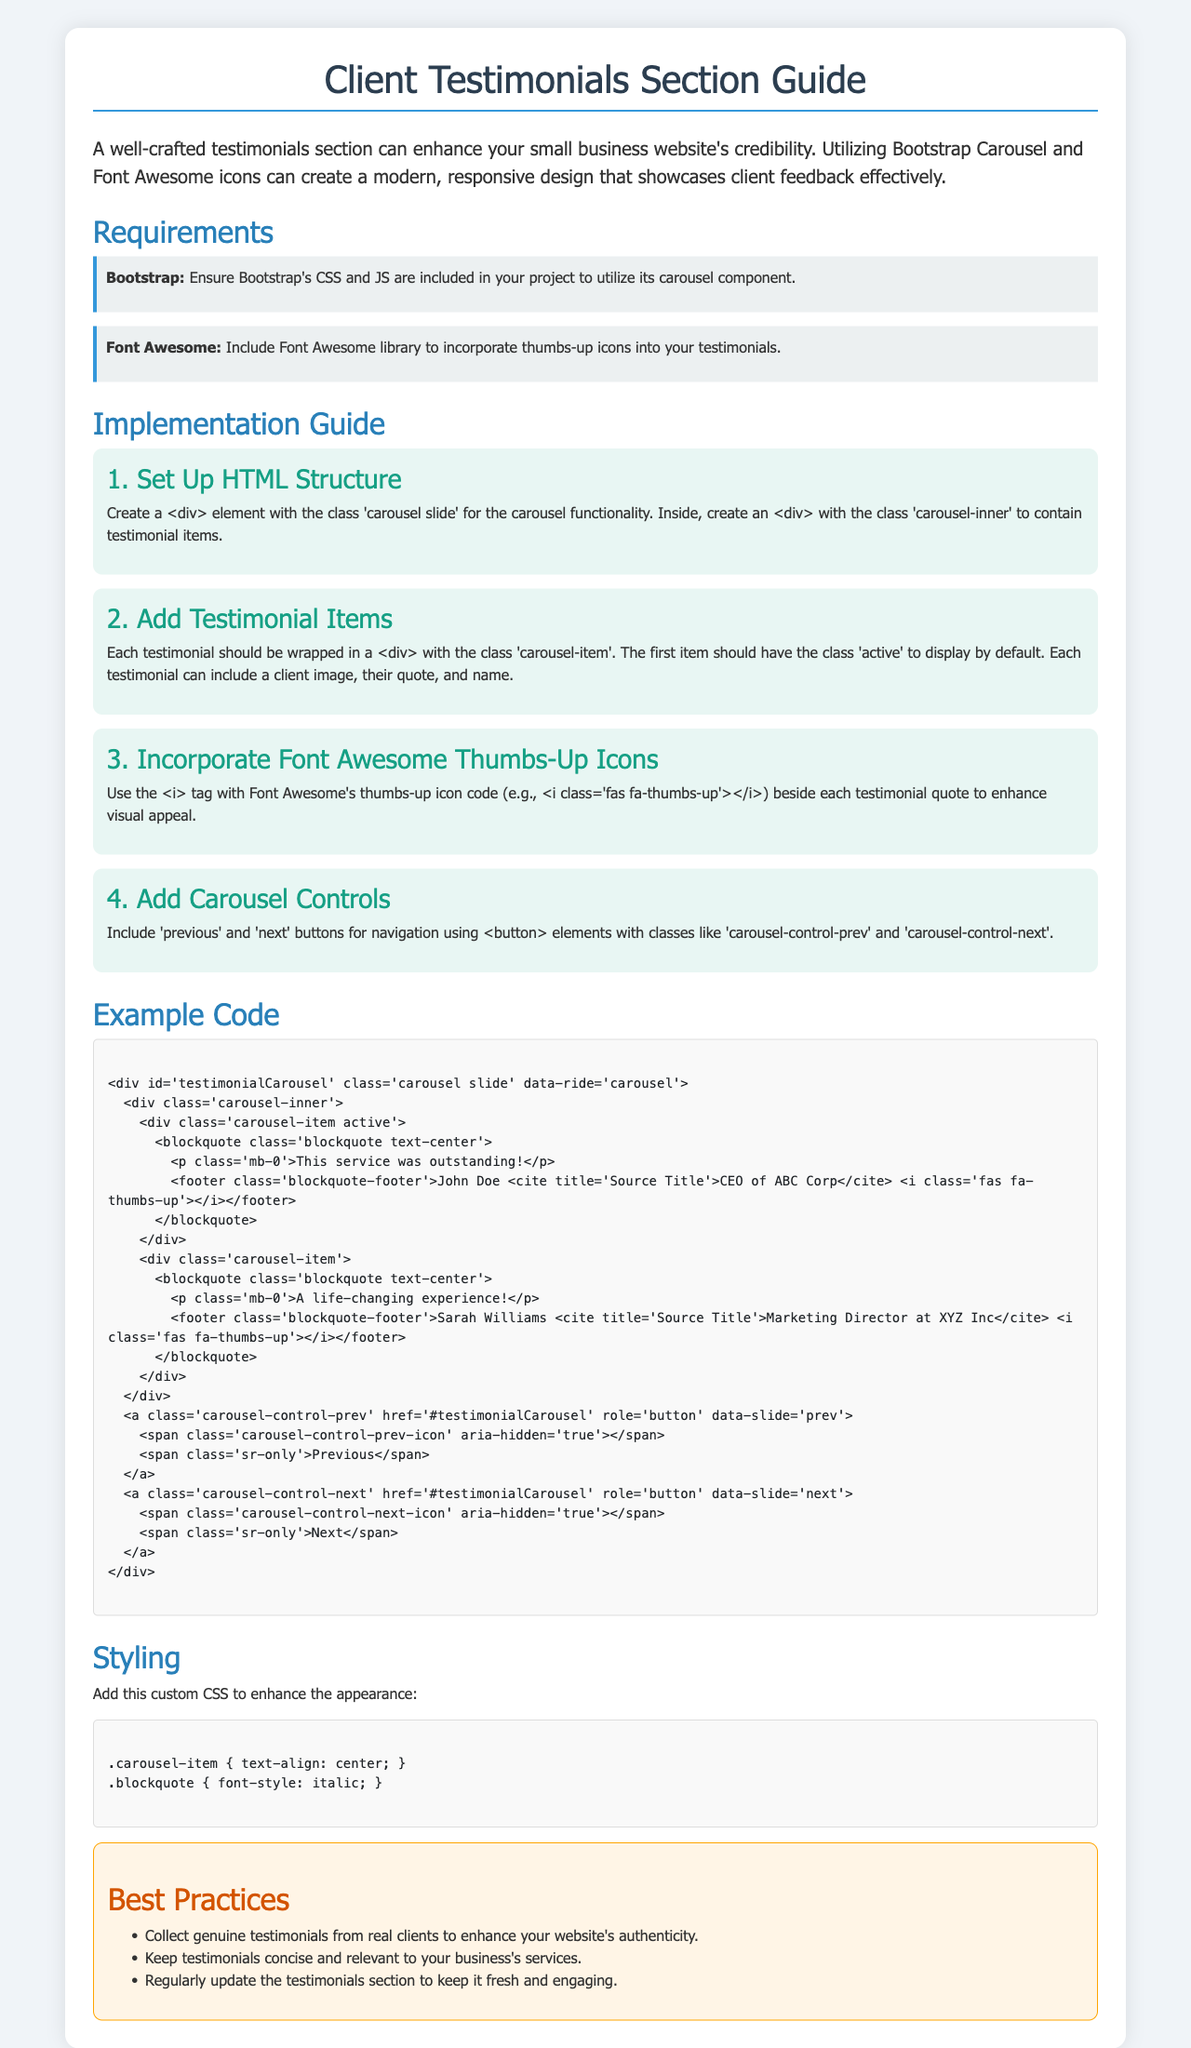What is the title of the document? The title is mentioned in the `<title>` tag of the HTML code, which is "Client Testimonials Guide".
Answer: Client Testimonials Guide How many testimonial items are included in the example code? The example code contains two instances of the carousel-item class, indicating there are two testimonials.
Answer: 2 What color is used for the thumbs-up icon? The CSS class `fa-thumbs-up` sets the color to a specific blue value mentioned in the style section.
Answer: blue What is the first testimonial quote in the example code? The first testimonial quote is found in the `blockquote` element of the first carousel-item.
Answer: This service was outstanding! What does the best practices section recommend about testimonials? The best practices section mentions to collect genuine testimonials from real clients for authenticity.
Answer: Collect genuine testimonials What is the Bootstrap version referenced in the document? The document links to a specific Bootstrap CSS file in the `<link>` tag, indicating the version used.
Answer: 4.5.2 Which icon library is used in this manual? The Font Awesome library is referenced through a `<link>` element in the head of the HTML document.
Answer: Font Awesome What should each testimonial contain according to the guide? The guide recommends that each testimonial should include a client image, their quote, and name.
Answer: Client image, quote, name What are the classes used for carousel navigation buttons? The classes mentioned for navigation buttons in the code are carousel-control-prev and carousel-control-next.
Answer: carousel-control-prev, carousel-control-next 